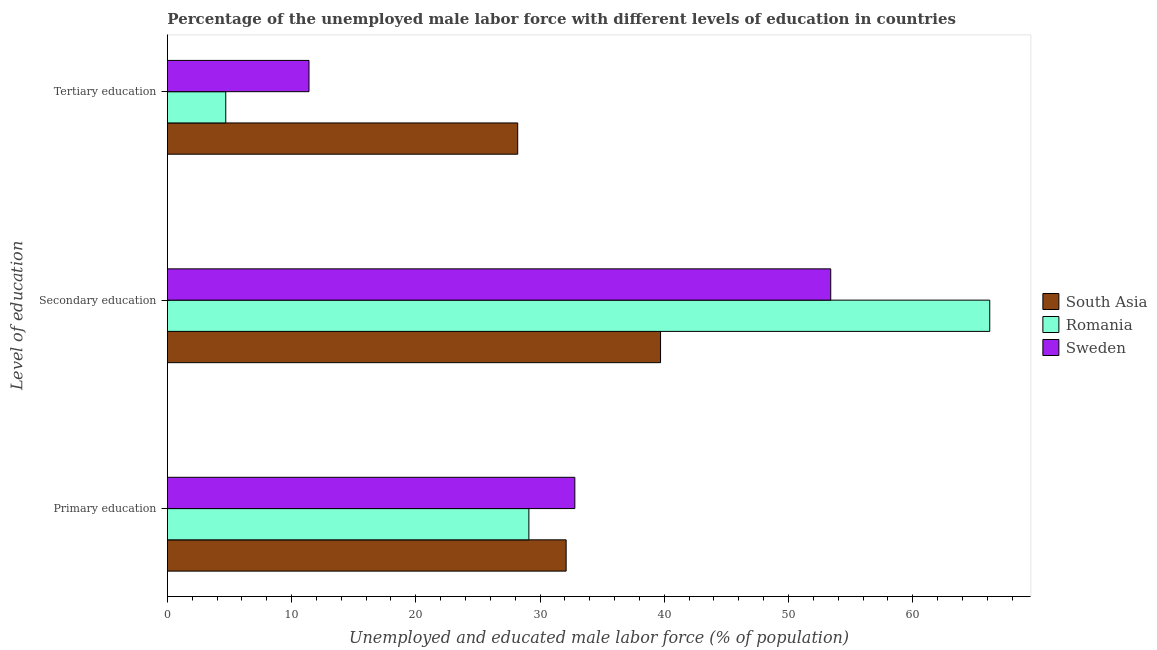How many different coloured bars are there?
Make the answer very short. 3. How many bars are there on the 1st tick from the top?
Give a very brief answer. 3. What is the label of the 1st group of bars from the top?
Ensure brevity in your answer.  Tertiary education. What is the percentage of male labor force who received secondary education in South Asia?
Provide a short and direct response. 39.7. Across all countries, what is the maximum percentage of male labor force who received primary education?
Make the answer very short. 32.8. Across all countries, what is the minimum percentage of male labor force who received primary education?
Ensure brevity in your answer.  29.1. What is the total percentage of male labor force who received secondary education in the graph?
Your answer should be compact. 159.3. What is the difference between the percentage of male labor force who received secondary education in Romania and that in Sweden?
Offer a very short reply. 12.8. What is the difference between the percentage of male labor force who received tertiary education in South Asia and the percentage of male labor force who received secondary education in Romania?
Offer a terse response. -38. What is the average percentage of male labor force who received secondary education per country?
Make the answer very short. 53.1. What is the difference between the percentage of male labor force who received secondary education and percentage of male labor force who received primary education in South Asia?
Make the answer very short. 7.6. What is the ratio of the percentage of male labor force who received primary education in Sweden to that in South Asia?
Give a very brief answer. 1.02. Is the difference between the percentage of male labor force who received secondary education in South Asia and Romania greater than the difference between the percentage of male labor force who received tertiary education in South Asia and Romania?
Make the answer very short. No. What is the difference between the highest and the second highest percentage of male labor force who received primary education?
Give a very brief answer. 0.7. What is the difference between the highest and the lowest percentage of male labor force who received primary education?
Provide a succinct answer. 3.7. Is the sum of the percentage of male labor force who received secondary education in South Asia and Sweden greater than the maximum percentage of male labor force who received primary education across all countries?
Ensure brevity in your answer.  Yes. What does the 2nd bar from the bottom in Primary education represents?
Your answer should be compact. Romania. Is it the case that in every country, the sum of the percentage of male labor force who received primary education and percentage of male labor force who received secondary education is greater than the percentage of male labor force who received tertiary education?
Provide a short and direct response. Yes. How many bars are there?
Give a very brief answer. 9. What is the difference between two consecutive major ticks on the X-axis?
Offer a very short reply. 10. Are the values on the major ticks of X-axis written in scientific E-notation?
Keep it short and to the point. No. Does the graph contain any zero values?
Your response must be concise. No. Does the graph contain grids?
Keep it short and to the point. No. How are the legend labels stacked?
Give a very brief answer. Vertical. What is the title of the graph?
Your answer should be very brief. Percentage of the unemployed male labor force with different levels of education in countries. Does "Brunei Darussalam" appear as one of the legend labels in the graph?
Provide a succinct answer. No. What is the label or title of the X-axis?
Make the answer very short. Unemployed and educated male labor force (% of population). What is the label or title of the Y-axis?
Offer a very short reply. Level of education. What is the Unemployed and educated male labor force (% of population) in South Asia in Primary education?
Ensure brevity in your answer.  32.1. What is the Unemployed and educated male labor force (% of population) in Romania in Primary education?
Offer a very short reply. 29.1. What is the Unemployed and educated male labor force (% of population) in Sweden in Primary education?
Provide a succinct answer. 32.8. What is the Unemployed and educated male labor force (% of population) of South Asia in Secondary education?
Your answer should be very brief. 39.7. What is the Unemployed and educated male labor force (% of population) in Romania in Secondary education?
Ensure brevity in your answer.  66.2. What is the Unemployed and educated male labor force (% of population) in Sweden in Secondary education?
Offer a terse response. 53.4. What is the Unemployed and educated male labor force (% of population) of South Asia in Tertiary education?
Your answer should be compact. 28.2. What is the Unemployed and educated male labor force (% of population) of Romania in Tertiary education?
Give a very brief answer. 4.7. What is the Unemployed and educated male labor force (% of population) in Sweden in Tertiary education?
Provide a succinct answer. 11.4. Across all Level of education, what is the maximum Unemployed and educated male labor force (% of population) of South Asia?
Your answer should be very brief. 39.7. Across all Level of education, what is the maximum Unemployed and educated male labor force (% of population) of Romania?
Give a very brief answer. 66.2. Across all Level of education, what is the maximum Unemployed and educated male labor force (% of population) in Sweden?
Give a very brief answer. 53.4. Across all Level of education, what is the minimum Unemployed and educated male labor force (% of population) in South Asia?
Provide a succinct answer. 28.2. Across all Level of education, what is the minimum Unemployed and educated male labor force (% of population) in Romania?
Offer a very short reply. 4.7. Across all Level of education, what is the minimum Unemployed and educated male labor force (% of population) in Sweden?
Provide a short and direct response. 11.4. What is the total Unemployed and educated male labor force (% of population) in Sweden in the graph?
Your answer should be very brief. 97.6. What is the difference between the Unemployed and educated male labor force (% of population) in South Asia in Primary education and that in Secondary education?
Your response must be concise. -7.6. What is the difference between the Unemployed and educated male labor force (% of population) in Romania in Primary education and that in Secondary education?
Offer a very short reply. -37.1. What is the difference between the Unemployed and educated male labor force (% of population) of Sweden in Primary education and that in Secondary education?
Ensure brevity in your answer.  -20.6. What is the difference between the Unemployed and educated male labor force (% of population) of Romania in Primary education and that in Tertiary education?
Your answer should be very brief. 24.4. What is the difference between the Unemployed and educated male labor force (% of population) in Sweden in Primary education and that in Tertiary education?
Give a very brief answer. 21.4. What is the difference between the Unemployed and educated male labor force (% of population) of Romania in Secondary education and that in Tertiary education?
Your answer should be very brief. 61.5. What is the difference between the Unemployed and educated male labor force (% of population) in South Asia in Primary education and the Unemployed and educated male labor force (% of population) in Romania in Secondary education?
Provide a succinct answer. -34.1. What is the difference between the Unemployed and educated male labor force (% of population) in South Asia in Primary education and the Unemployed and educated male labor force (% of population) in Sweden in Secondary education?
Offer a terse response. -21.3. What is the difference between the Unemployed and educated male labor force (% of population) of Romania in Primary education and the Unemployed and educated male labor force (% of population) of Sweden in Secondary education?
Offer a terse response. -24.3. What is the difference between the Unemployed and educated male labor force (% of population) in South Asia in Primary education and the Unemployed and educated male labor force (% of population) in Romania in Tertiary education?
Ensure brevity in your answer.  27.4. What is the difference between the Unemployed and educated male labor force (% of population) in South Asia in Primary education and the Unemployed and educated male labor force (% of population) in Sweden in Tertiary education?
Keep it short and to the point. 20.7. What is the difference between the Unemployed and educated male labor force (% of population) of South Asia in Secondary education and the Unemployed and educated male labor force (% of population) of Romania in Tertiary education?
Ensure brevity in your answer.  35. What is the difference between the Unemployed and educated male labor force (% of population) in South Asia in Secondary education and the Unemployed and educated male labor force (% of population) in Sweden in Tertiary education?
Your response must be concise. 28.3. What is the difference between the Unemployed and educated male labor force (% of population) of Romania in Secondary education and the Unemployed and educated male labor force (% of population) of Sweden in Tertiary education?
Offer a terse response. 54.8. What is the average Unemployed and educated male labor force (% of population) of South Asia per Level of education?
Provide a succinct answer. 33.33. What is the average Unemployed and educated male labor force (% of population) of Romania per Level of education?
Provide a succinct answer. 33.33. What is the average Unemployed and educated male labor force (% of population) of Sweden per Level of education?
Give a very brief answer. 32.53. What is the difference between the Unemployed and educated male labor force (% of population) in South Asia and Unemployed and educated male labor force (% of population) in Romania in Primary education?
Provide a short and direct response. 3. What is the difference between the Unemployed and educated male labor force (% of population) in South Asia and Unemployed and educated male labor force (% of population) in Sweden in Primary education?
Offer a very short reply. -0.7. What is the difference between the Unemployed and educated male labor force (% of population) of South Asia and Unemployed and educated male labor force (% of population) of Romania in Secondary education?
Your answer should be very brief. -26.5. What is the difference between the Unemployed and educated male labor force (% of population) in South Asia and Unemployed and educated male labor force (% of population) in Sweden in Secondary education?
Offer a very short reply. -13.7. What is the difference between the Unemployed and educated male labor force (% of population) of South Asia and Unemployed and educated male labor force (% of population) of Romania in Tertiary education?
Make the answer very short. 23.5. What is the ratio of the Unemployed and educated male labor force (% of population) of South Asia in Primary education to that in Secondary education?
Keep it short and to the point. 0.81. What is the ratio of the Unemployed and educated male labor force (% of population) of Romania in Primary education to that in Secondary education?
Keep it short and to the point. 0.44. What is the ratio of the Unemployed and educated male labor force (% of population) in Sweden in Primary education to that in Secondary education?
Make the answer very short. 0.61. What is the ratio of the Unemployed and educated male labor force (% of population) in South Asia in Primary education to that in Tertiary education?
Provide a short and direct response. 1.14. What is the ratio of the Unemployed and educated male labor force (% of population) in Romania in Primary education to that in Tertiary education?
Your response must be concise. 6.19. What is the ratio of the Unemployed and educated male labor force (% of population) of Sweden in Primary education to that in Tertiary education?
Offer a terse response. 2.88. What is the ratio of the Unemployed and educated male labor force (% of population) of South Asia in Secondary education to that in Tertiary education?
Give a very brief answer. 1.41. What is the ratio of the Unemployed and educated male labor force (% of population) in Romania in Secondary education to that in Tertiary education?
Give a very brief answer. 14.09. What is the ratio of the Unemployed and educated male labor force (% of population) of Sweden in Secondary education to that in Tertiary education?
Your answer should be very brief. 4.68. What is the difference between the highest and the second highest Unemployed and educated male labor force (% of population) of Romania?
Keep it short and to the point. 37.1. What is the difference between the highest and the second highest Unemployed and educated male labor force (% of population) of Sweden?
Keep it short and to the point. 20.6. What is the difference between the highest and the lowest Unemployed and educated male labor force (% of population) in South Asia?
Make the answer very short. 11.5. What is the difference between the highest and the lowest Unemployed and educated male labor force (% of population) in Romania?
Provide a short and direct response. 61.5. 